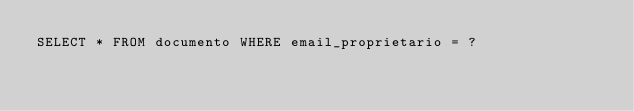<code> <loc_0><loc_0><loc_500><loc_500><_SQL_>SELECT * FROM documento WHERE email_proprietario = ?</code> 